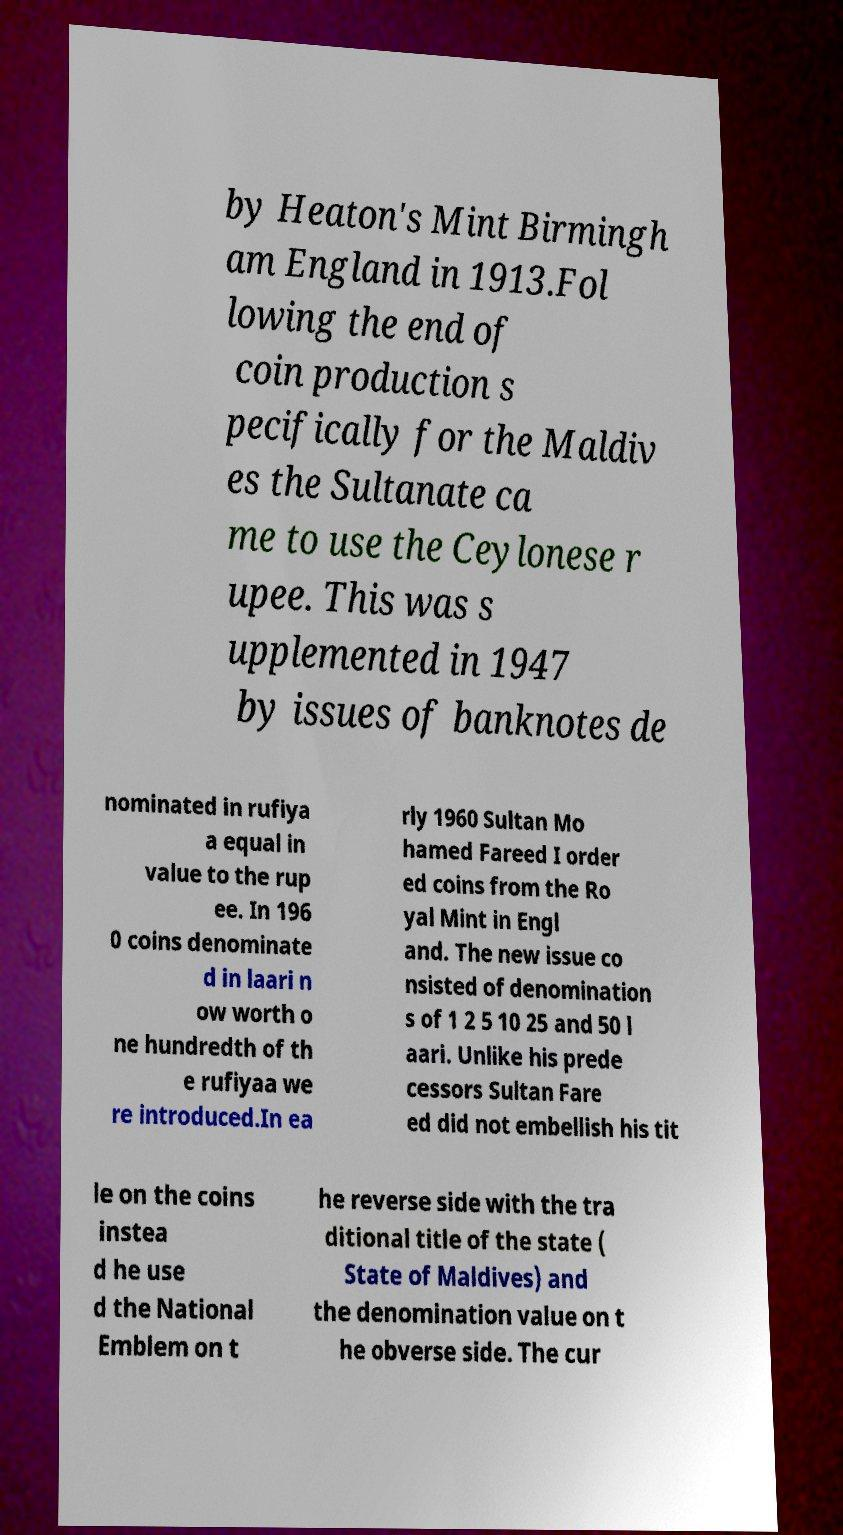Please identify and transcribe the text found in this image. by Heaton's Mint Birmingh am England in 1913.Fol lowing the end of coin production s pecifically for the Maldiv es the Sultanate ca me to use the Ceylonese r upee. This was s upplemented in 1947 by issues of banknotes de nominated in rufiya a equal in value to the rup ee. In 196 0 coins denominate d in laari n ow worth o ne hundredth of th e rufiyaa we re introduced.In ea rly 1960 Sultan Mo hamed Fareed I order ed coins from the Ro yal Mint in Engl and. The new issue co nsisted of denomination s of 1 2 5 10 25 and 50 l aari. Unlike his prede cessors Sultan Fare ed did not embellish his tit le on the coins instea d he use d the National Emblem on t he reverse side with the tra ditional title of the state ( State of Maldives) and the denomination value on t he obverse side. The cur 